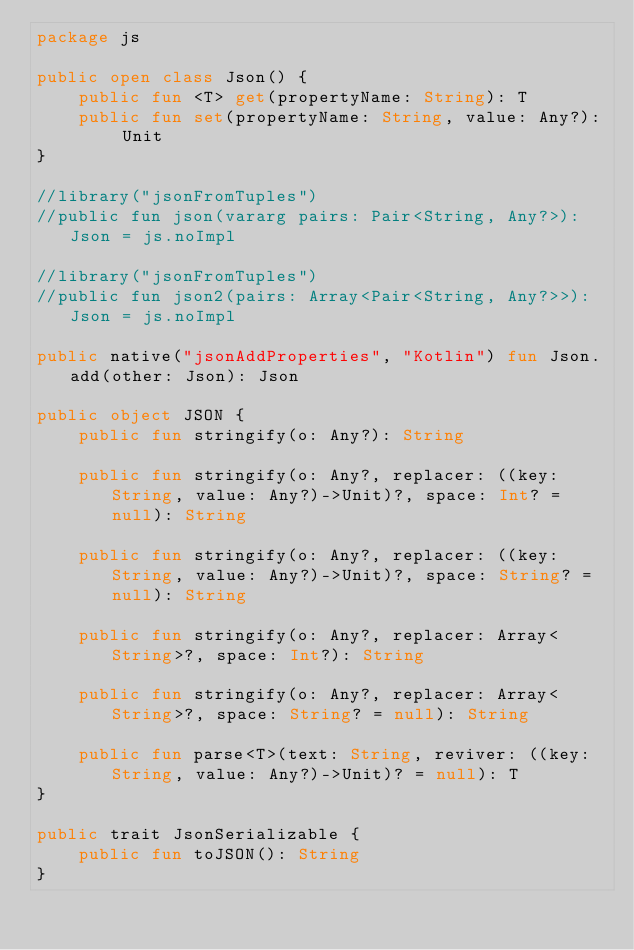Convert code to text. <code><loc_0><loc_0><loc_500><loc_500><_Kotlin_>package js

public open class Json() {
    public fun <T> get(propertyName: String): T
    public fun set(propertyName: String, value: Any?): Unit
}

//library("jsonFromTuples")
//public fun json(vararg pairs: Pair<String, Any?>): Json = js.noImpl

//library("jsonFromTuples")
//public fun json2(pairs: Array<Pair<String, Any?>>): Json = js.noImpl

public native("jsonAddProperties", "Kotlin") fun Json.add(other: Json): Json

public object JSON {
    public fun stringify(o: Any?): String

    public fun stringify(o: Any?, replacer: ((key: String, value: Any?)->Unit)?, space: Int? = null): String

    public fun stringify(o: Any?, replacer: ((key: String, value: Any?)->Unit)?, space: String? = null): String

    public fun stringify(o: Any?, replacer: Array<String>?, space: Int?): String

    public fun stringify(o: Any?, replacer: Array<String>?, space: String? = null): String

    public fun parse<T>(text: String, reviver: ((key: String, value: Any?)->Unit)? = null): T
}

public trait JsonSerializable {
    public fun toJSON(): String
}</code> 